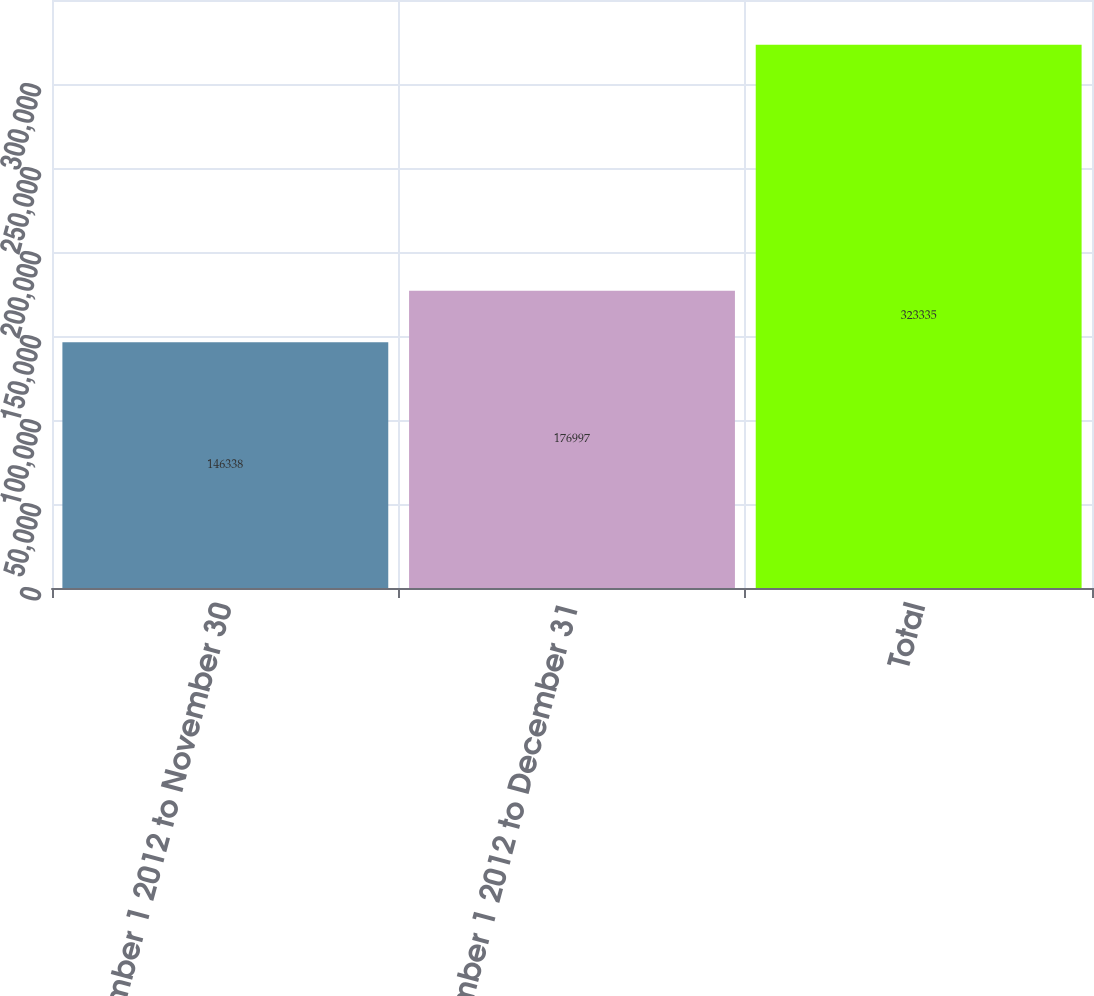Convert chart. <chart><loc_0><loc_0><loc_500><loc_500><bar_chart><fcel>November 1 2012 to November 30<fcel>December 1 2012 to December 31<fcel>Total<nl><fcel>146338<fcel>176997<fcel>323335<nl></chart> 